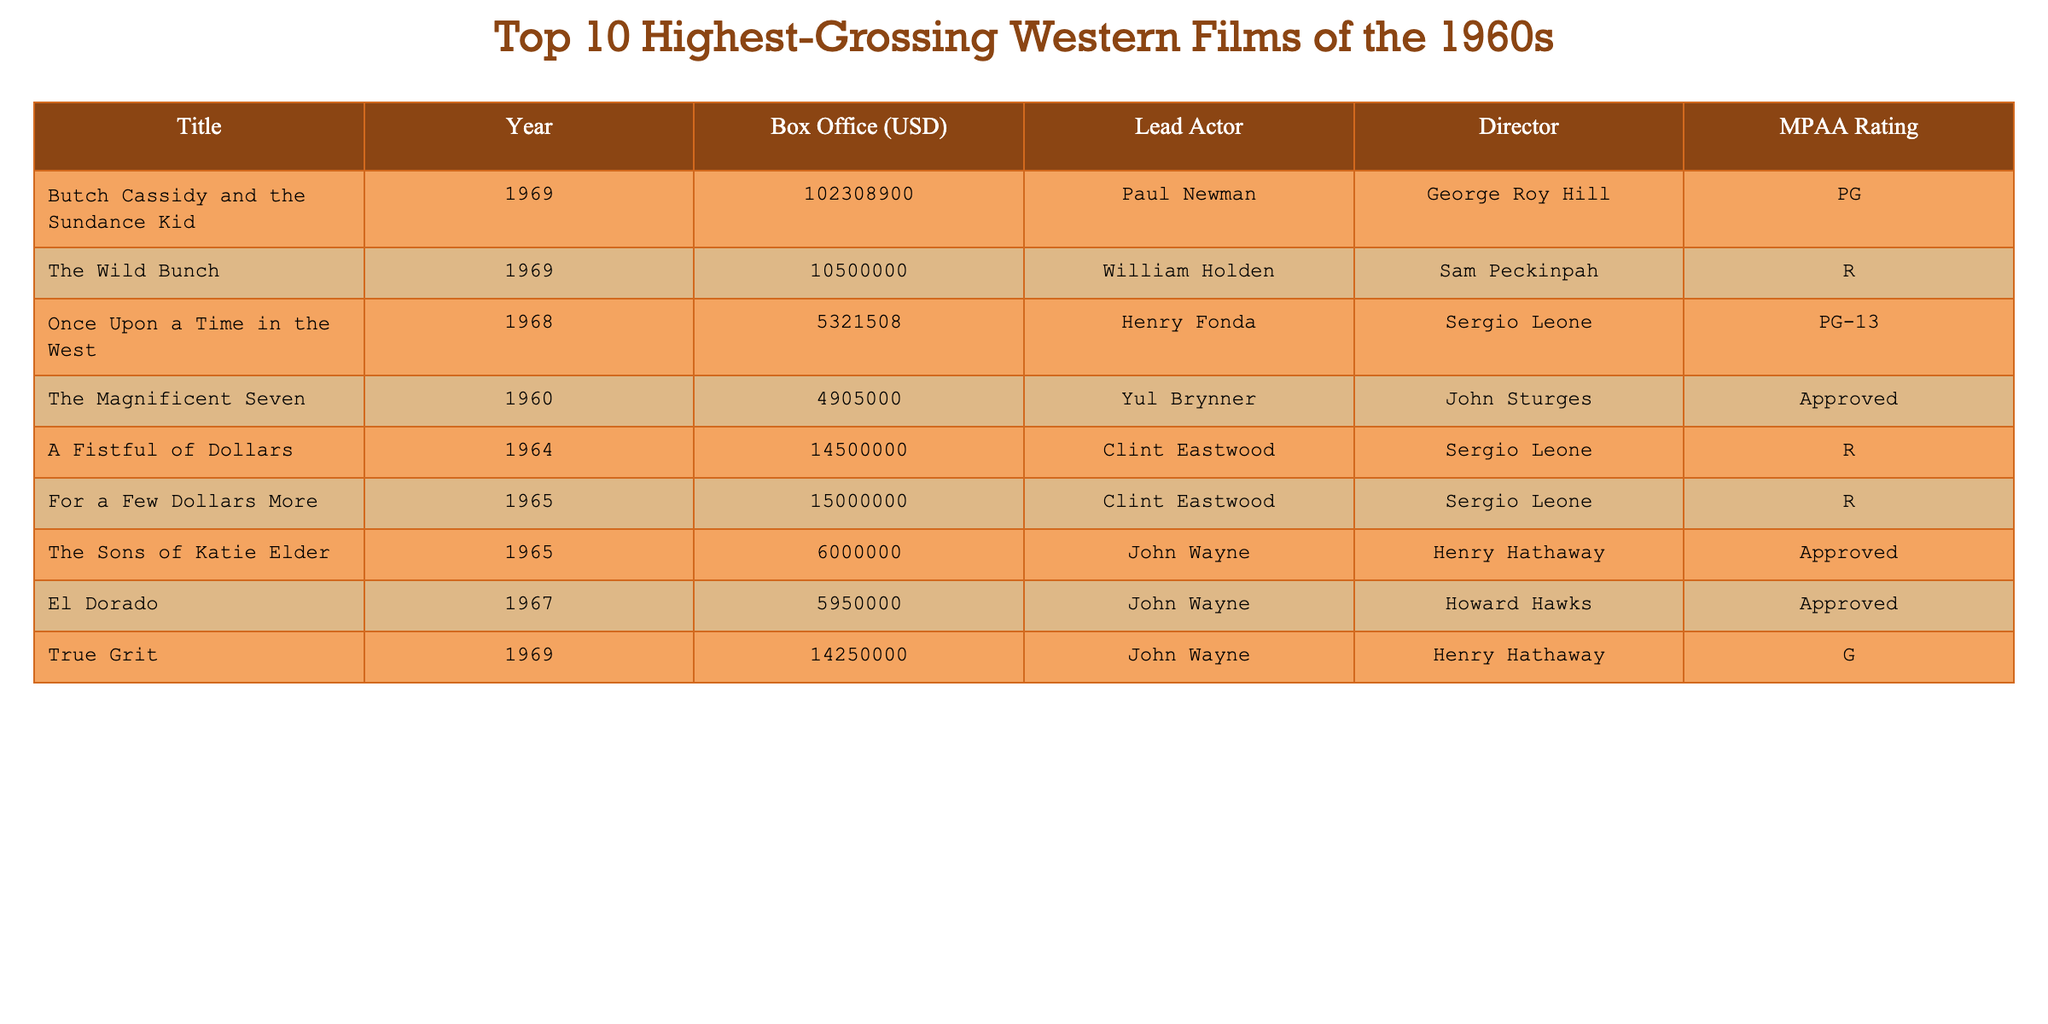What is the highest-grossing Western film of the 1960s? The table shows the box office figures for various films. "Butch Cassidy and the Sundance Kid" has the highest box office amount at 102,308,900 USD.
Answer: Butch Cassidy and the Sundance Kid Which film had the lowest box office gross in the 1960s? Looking at the box office figures, "Once Upon a Time in the West" has the lowest gross of 5,321,508 USD compared to the other films listed.
Answer: Once Upon a Time in the West How many films in the table were directed by Sergio Leone? The table lists "A Fistful of Dollars," "For a Few Dollars More," and "Once Upon a Time in the West," making a total of 3 films directed by Sergio Leone.
Answer: 3 What was the total box office gross for the top three highest-grossing films? The top three films are "Butch Cassidy and the Sundance Kid" (102,308,900 USD), "The Wild Bunch" (10,500,000 USD), and "True Grit" (14,250,000 USD). The total is 102,308,900 + 10,500,000 + 14,250,000 = 127,058,900 USD.
Answer: 127,058,900 Which actor appeared in the most films on the list? John Wayne appears in two films: "The Sons of Katie Elder" and "El Dorado," while Clint Eastwood also appears in two films: "A Fistful of Dollars" and "For a Few Dollars More." However, there is no single actor who appears more than others.
Answer: John Wayne and Clint Eastwood Is there a film in the table that has a G rating? Yes, "True Grit" has a G rating according to the MPAA Rating column in the table.
Answer: Yes What is the average box office gross of the films directed by Sergio Leone? The box office for "A Fistful of Dollars" is 14,500,000 USD, "For a Few Dollars More" is 15,000,000 USD, and "Once Upon a Time in the West" is 5,321,508 USD. The average is (14,500,000 + 15,000,000 + 5,321,508) / 3 = 11,273,169.33 USD.
Answer: 11,273,169.33 Which film had a box office gross more than 10 million USD and was released in 1969? The film "Butch Cassidy and the Sundance Kid" with a gross of 102,308,900 USD and "True Grit" with 14,250,000 USD both meet the criteria as they were released in 1969 and have grossed more than 10 million USD.
Answer: Butch Cassidy and the Sundance Kid, True Grit How many films listed received a rating of 'R'? The table shows that there are 3 films rated 'R': "The Wild Bunch," "A Fistful of Dollars," and "For a Few Dollars More."
Answer: 3 Was "The Magnificent Seven" financially successful compared to "El Dorado"? "The Magnificent Seven" grossed 4,905,000 USD while "El Dorado" grossed 5,950,000 USD, meaning "El Dorado" was more financially successful.
Answer: Yes, El Dorado was more successful 